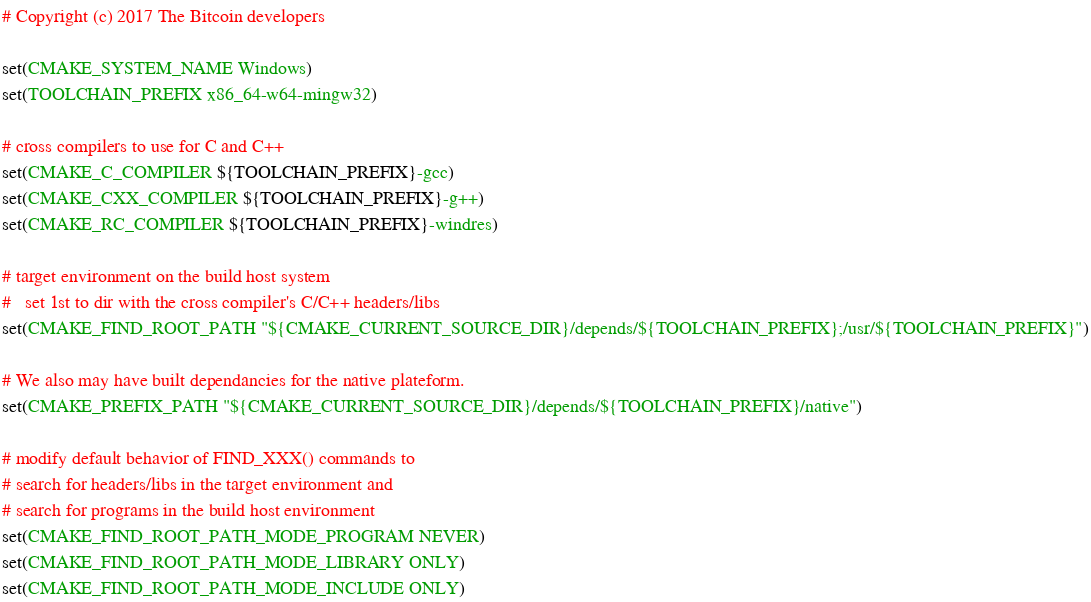<code> <loc_0><loc_0><loc_500><loc_500><_CMake_># Copyright (c) 2017 The Bitcoin developers

set(CMAKE_SYSTEM_NAME Windows)
set(TOOLCHAIN_PREFIX x86_64-w64-mingw32)

# cross compilers to use for C and C++
set(CMAKE_C_COMPILER ${TOOLCHAIN_PREFIX}-gcc)
set(CMAKE_CXX_COMPILER ${TOOLCHAIN_PREFIX}-g++)
set(CMAKE_RC_COMPILER ${TOOLCHAIN_PREFIX}-windres)

# target environment on the build host system
#   set 1st to dir with the cross compiler's C/C++ headers/libs
set(CMAKE_FIND_ROOT_PATH "${CMAKE_CURRENT_SOURCE_DIR}/depends/${TOOLCHAIN_PREFIX};/usr/${TOOLCHAIN_PREFIX}")

# We also may have built dependancies for the native plateform.
set(CMAKE_PREFIX_PATH "${CMAKE_CURRENT_SOURCE_DIR}/depends/${TOOLCHAIN_PREFIX}/native")

# modify default behavior of FIND_XXX() commands to
# search for headers/libs in the target environment and
# search for programs in the build host environment
set(CMAKE_FIND_ROOT_PATH_MODE_PROGRAM NEVER)
set(CMAKE_FIND_ROOT_PATH_MODE_LIBRARY ONLY)
set(CMAKE_FIND_ROOT_PATH_MODE_INCLUDE ONLY)
</code> 